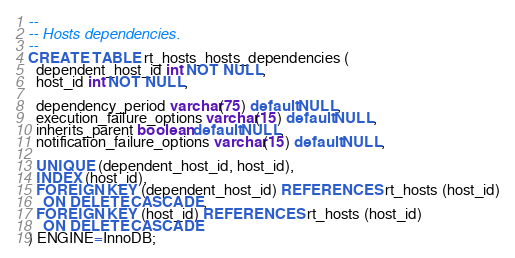Convert code to text. <code><loc_0><loc_0><loc_500><loc_500><_SQL_>--
-- Hosts dependencies.
--
CREATE TABLE rt_hosts_hosts_dependencies (
  dependent_host_id int NOT NULL,
  host_id int NOT NULL,

  dependency_period varchar(75) default NULL,
  execution_failure_options varchar(15) default NULL,
  inherits_parent boolean default NULL,
  notification_failure_options varchar(15) default NULL,

  UNIQUE (dependent_host_id, host_id),
  INDEX (host_id),
  FOREIGN KEY (dependent_host_id) REFERENCES rt_hosts (host_id)
    ON DELETE CASCADE,
  FOREIGN KEY (host_id) REFERENCES rt_hosts (host_id)
    ON DELETE CASCADE
) ENGINE=InnoDB;
</code> 